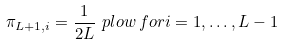<formula> <loc_0><loc_0><loc_500><loc_500>\pi _ { L + 1 , i } = \frac { 1 } { 2 L } \ p l o w \, f o r i = 1 , \dots , L - 1</formula> 